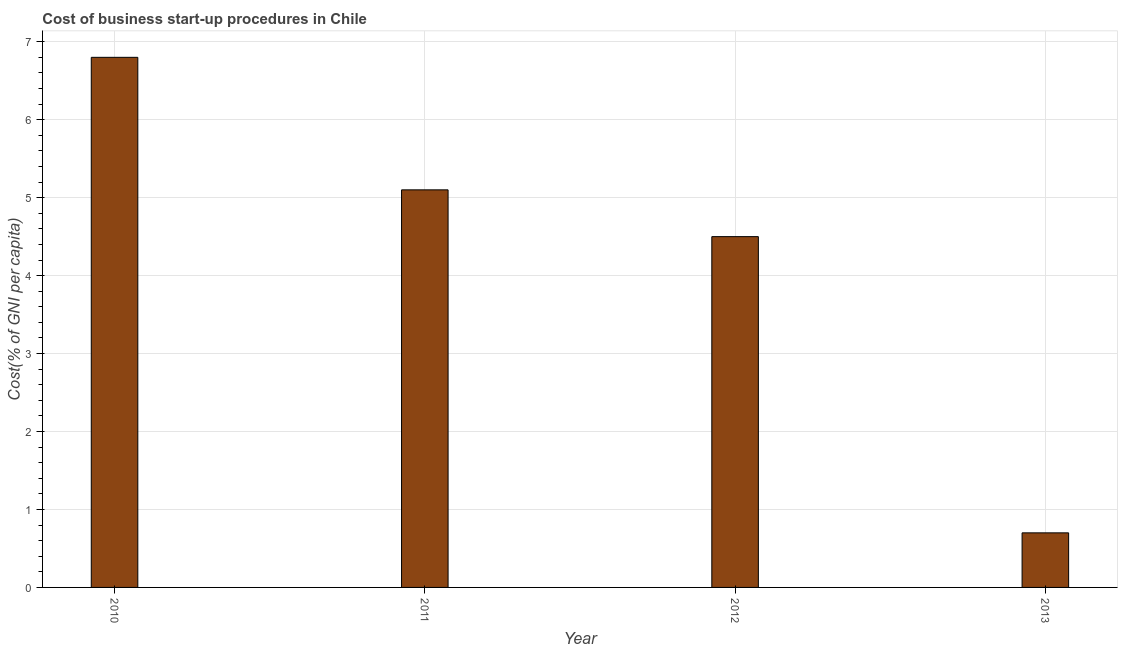Does the graph contain grids?
Your answer should be compact. Yes. What is the title of the graph?
Your answer should be compact. Cost of business start-up procedures in Chile. What is the label or title of the Y-axis?
Ensure brevity in your answer.  Cost(% of GNI per capita). What is the cost of business startup procedures in 2012?
Your answer should be very brief. 4.5. Across all years, what is the maximum cost of business startup procedures?
Your response must be concise. 6.8. Across all years, what is the minimum cost of business startup procedures?
Keep it short and to the point. 0.7. In which year was the cost of business startup procedures maximum?
Ensure brevity in your answer.  2010. In which year was the cost of business startup procedures minimum?
Offer a terse response. 2013. What is the sum of the cost of business startup procedures?
Give a very brief answer. 17.1. What is the average cost of business startup procedures per year?
Your response must be concise. 4.28. What is the median cost of business startup procedures?
Ensure brevity in your answer.  4.8. In how many years, is the cost of business startup procedures greater than 0.6 %?
Give a very brief answer. 4. What is the ratio of the cost of business startup procedures in 2010 to that in 2013?
Your response must be concise. 9.71. Is the cost of business startup procedures in 2012 less than that in 2013?
Your response must be concise. No. Is the difference between the cost of business startup procedures in 2012 and 2013 greater than the difference between any two years?
Provide a succinct answer. No. Is the sum of the cost of business startup procedures in 2012 and 2013 greater than the maximum cost of business startup procedures across all years?
Your answer should be very brief. No. What is the difference between the highest and the lowest cost of business startup procedures?
Your response must be concise. 6.1. In how many years, is the cost of business startup procedures greater than the average cost of business startup procedures taken over all years?
Give a very brief answer. 3. Are all the bars in the graph horizontal?
Ensure brevity in your answer.  No. What is the Cost(% of GNI per capita) of 2011?
Offer a very short reply. 5.1. What is the Cost(% of GNI per capita) in 2012?
Your answer should be very brief. 4.5. What is the Cost(% of GNI per capita) in 2013?
Keep it short and to the point. 0.7. What is the difference between the Cost(% of GNI per capita) in 2010 and 2011?
Give a very brief answer. 1.7. What is the difference between the Cost(% of GNI per capita) in 2010 and 2012?
Your answer should be compact. 2.3. What is the difference between the Cost(% of GNI per capita) in 2010 and 2013?
Your answer should be compact. 6.1. What is the difference between the Cost(% of GNI per capita) in 2011 and 2012?
Keep it short and to the point. 0.6. What is the difference between the Cost(% of GNI per capita) in 2012 and 2013?
Give a very brief answer. 3.8. What is the ratio of the Cost(% of GNI per capita) in 2010 to that in 2011?
Make the answer very short. 1.33. What is the ratio of the Cost(% of GNI per capita) in 2010 to that in 2012?
Your answer should be very brief. 1.51. What is the ratio of the Cost(% of GNI per capita) in 2010 to that in 2013?
Keep it short and to the point. 9.71. What is the ratio of the Cost(% of GNI per capita) in 2011 to that in 2012?
Keep it short and to the point. 1.13. What is the ratio of the Cost(% of GNI per capita) in 2011 to that in 2013?
Offer a very short reply. 7.29. What is the ratio of the Cost(% of GNI per capita) in 2012 to that in 2013?
Provide a succinct answer. 6.43. 